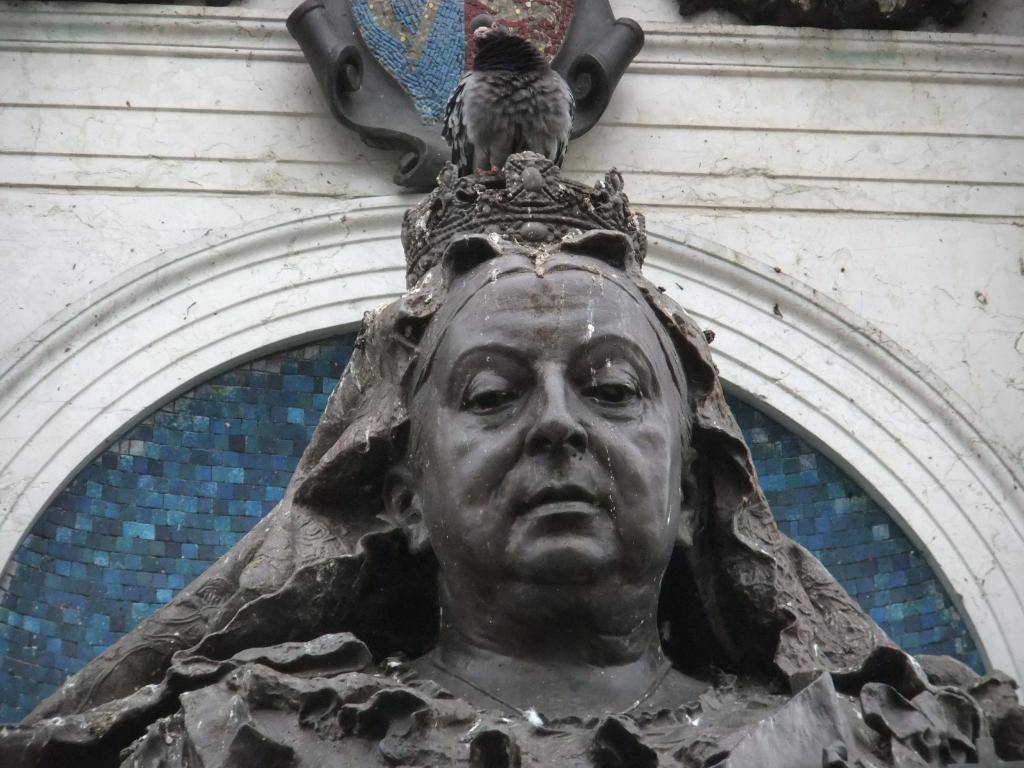How would you summarize this image in a sentence or two? In this image we can see a pigeon standing on the statue and a wall in the background. 